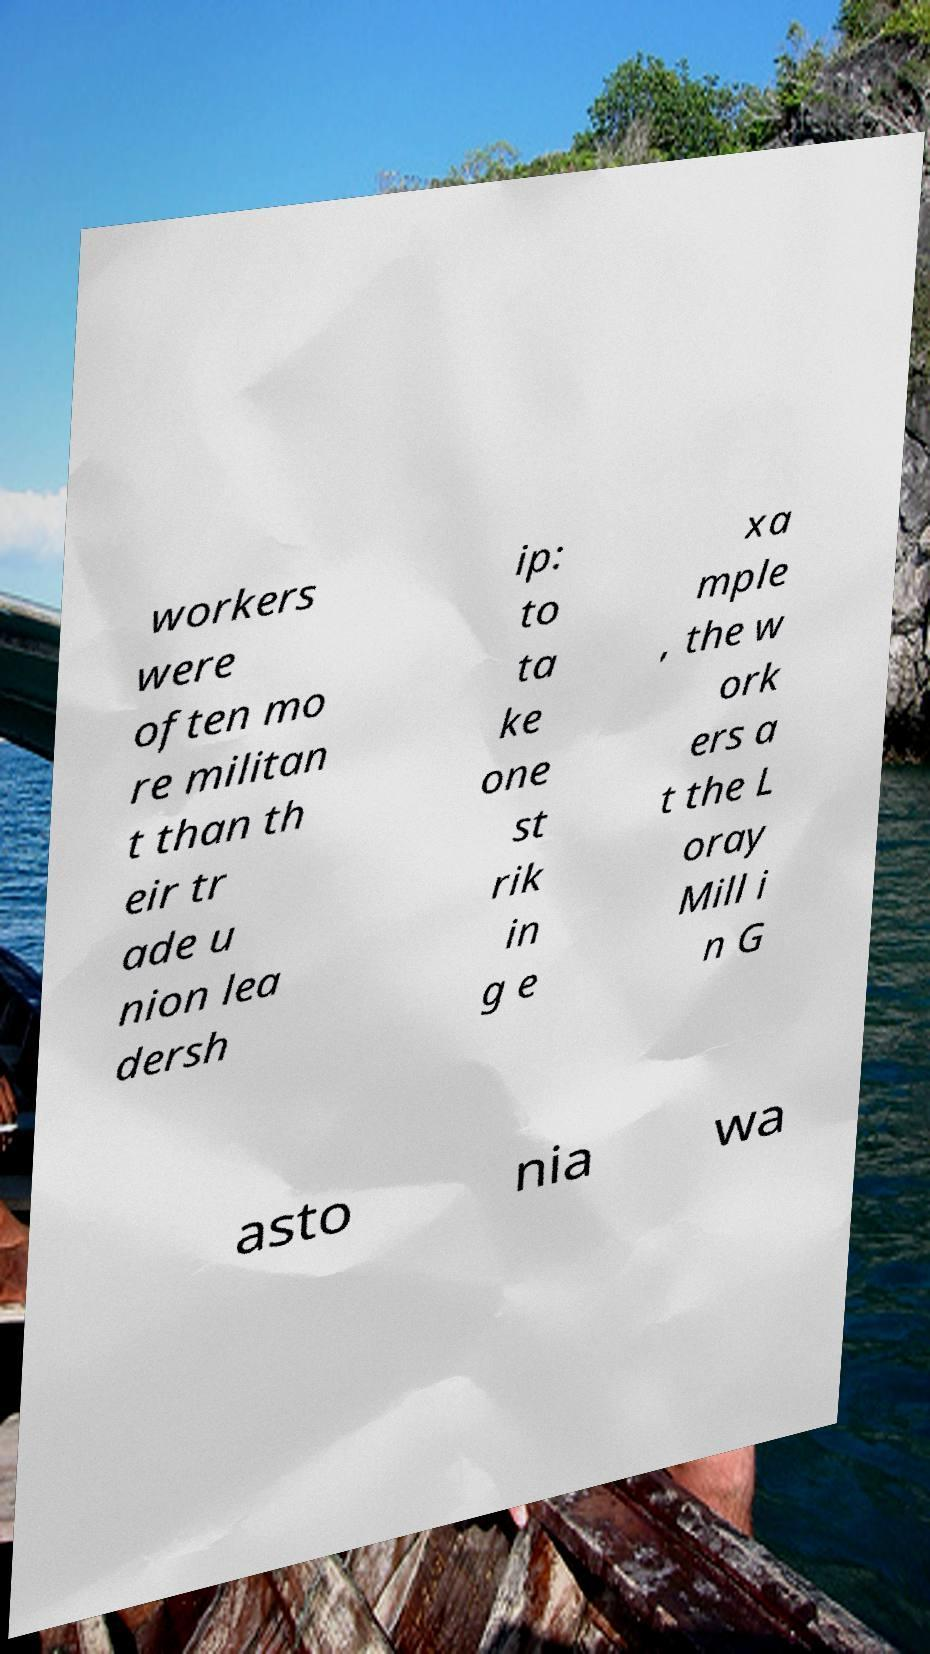There's text embedded in this image that I need extracted. Can you transcribe it verbatim? workers were often mo re militan t than th eir tr ade u nion lea dersh ip: to ta ke one st rik in g e xa mple , the w ork ers a t the L oray Mill i n G asto nia wa 